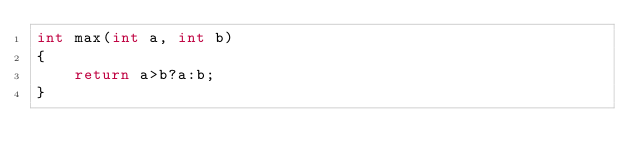Convert code to text. <code><loc_0><loc_0><loc_500><loc_500><_C++_>int max(int a, int b)
{
	return a>b?a:b;
}
</code> 